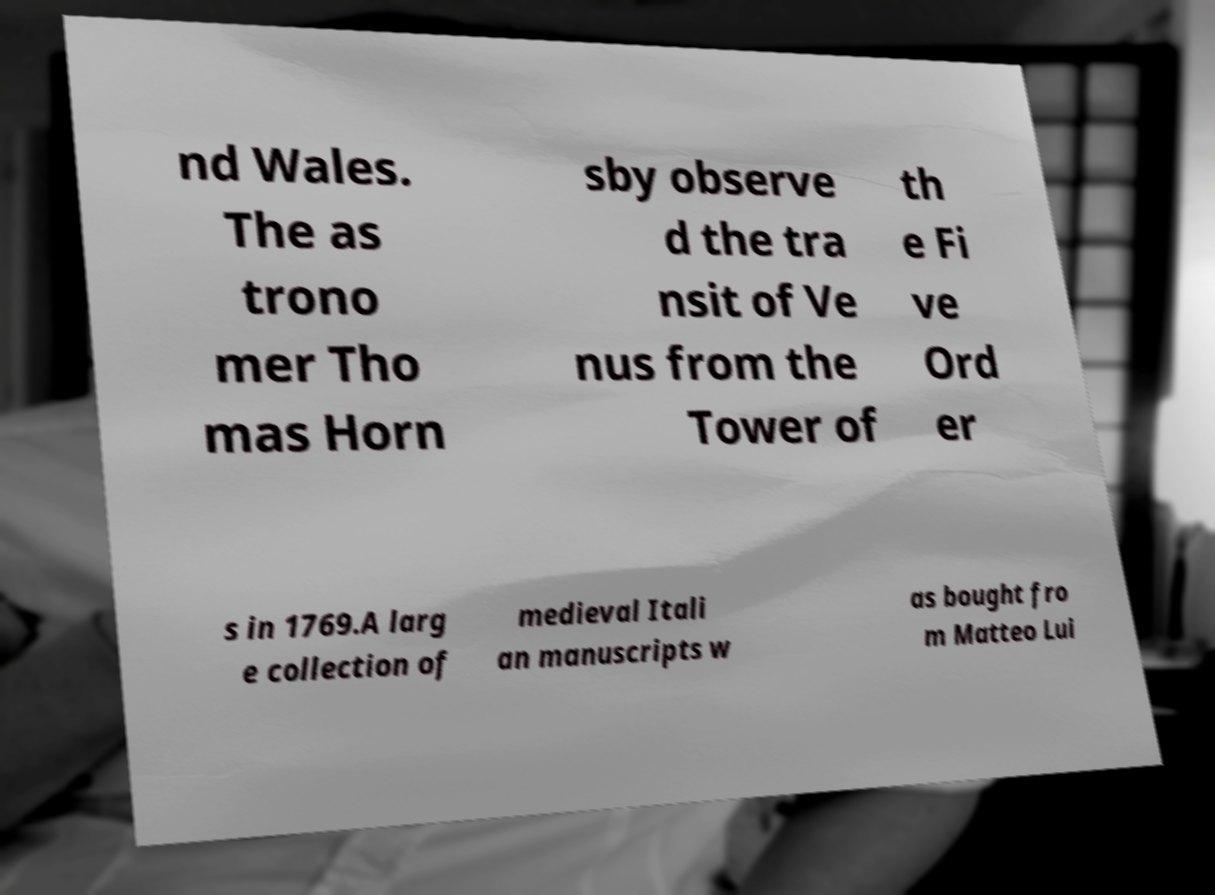Can you read and provide the text displayed in the image?This photo seems to have some interesting text. Can you extract and type it out for me? nd Wales. The as trono mer Tho mas Horn sby observe d the tra nsit of Ve nus from the Tower of th e Fi ve Ord er s in 1769.A larg e collection of medieval Itali an manuscripts w as bought fro m Matteo Lui 